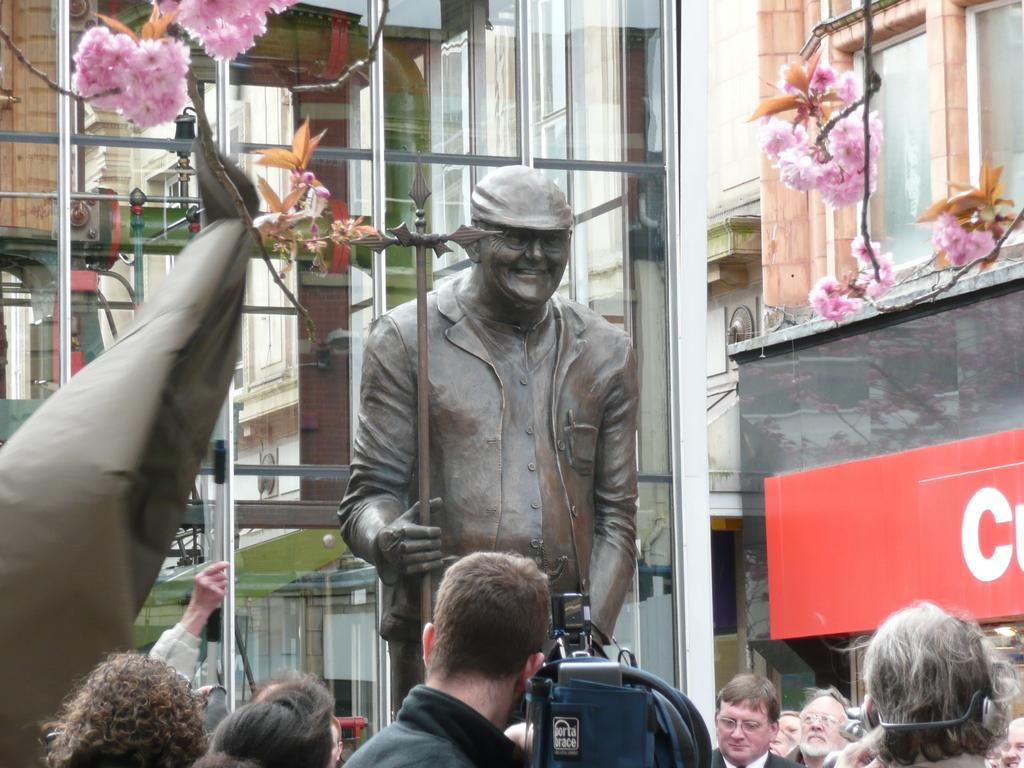How many people are in the group visible in the image? There is a group of people in the image, but the exact number cannot be determined from the provided facts. What type of flora is present in the image? There are flowers in the image. What is the statue in the image depicting? The statue in the image is of a person smiling. What else can be seen in the image besides the people, flowers, and statue? There are objects in the image. What can be seen in the background of the image? There are buildings in the background of the image. What type of apple is being used as a shock absorber in the image? There is no apple or any shock absorber present in the image. Who is the partner of the person depicted in the statue in the image? The statue in the image is of a person smiling, but there is no mention of a partner or any other person in the image. 